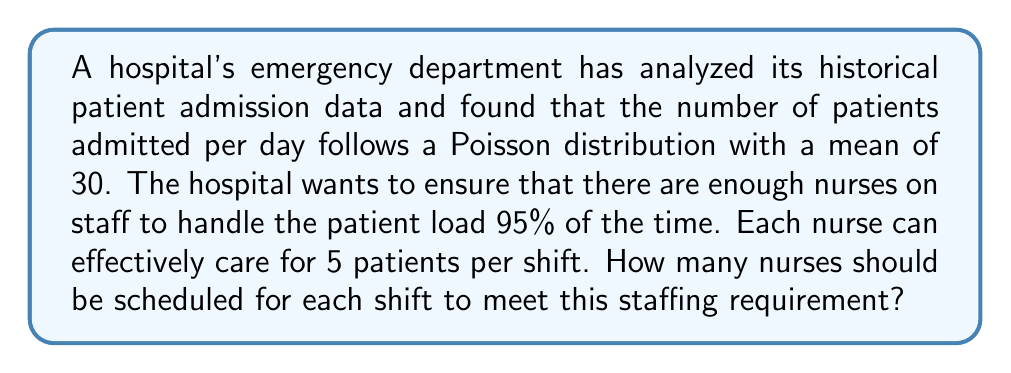Help me with this question. To solve this problem, we need to follow these steps:

1) First, we need to find the number of patients that would cover 95% of all possible scenarios. This can be done using the inverse cumulative distribution function of the Poisson distribution.

2) For a Poisson distribution with mean $\lambda = 30$, we need to find the value $x$ such that:

   $$P(X \leq x) = 0.95$$

3) Using a Poisson probability table or a statistical software, we can find that $x = 39$. This means that 95% of the time, there will be 39 or fewer patients admitted per day.

4) Now that we know we need to be prepared for up to 39 patients, we can calculate the number of nurses needed:

   $$\text{Number of nurses} = \left\lceil\frac{\text{Number of patients}}{\text{Patients per nurse}}\right\rceil$$

5) Substituting our values:

   $$\text{Number of nurses} = \left\lceil\frac{39}{5}\right\rceil$$

6) Calculating:

   $$\text{Number of nurses} = \left\lceil7.8\right\rceil = 8$$

The ceiling function $\lceil \rceil$ is used because we need to round up to the nearest whole number of nurses.
Answer: 8 nurses should be scheduled for each shift to meet the staffing requirement. 